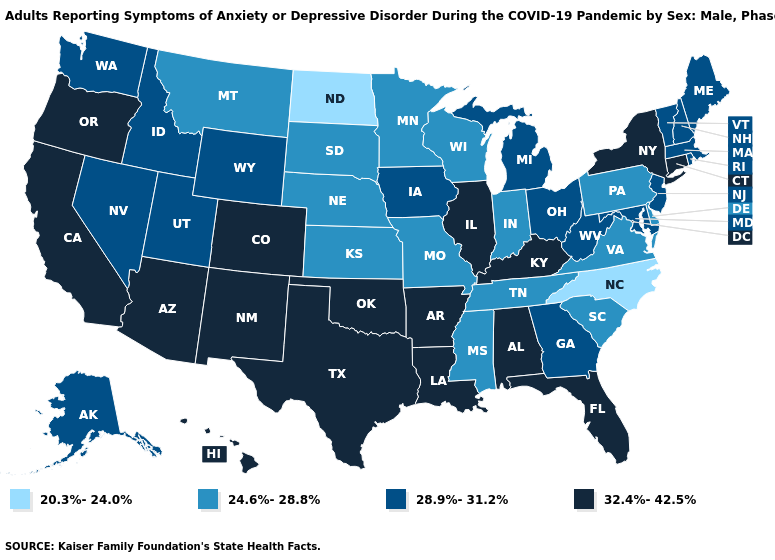Among the states that border Kansas , which have the lowest value?
Quick response, please. Missouri, Nebraska. Which states have the lowest value in the USA?
Answer briefly. North Carolina, North Dakota. Among the states that border Wyoming , which have the lowest value?
Be succinct. Montana, Nebraska, South Dakota. Name the states that have a value in the range 28.9%-31.2%?
Concise answer only. Alaska, Georgia, Idaho, Iowa, Maine, Maryland, Massachusetts, Michigan, Nevada, New Hampshire, New Jersey, Ohio, Rhode Island, Utah, Vermont, Washington, West Virginia, Wyoming. What is the lowest value in the USA?
Concise answer only. 20.3%-24.0%. Does North Dakota have the lowest value in the MidWest?
Write a very short answer. Yes. How many symbols are there in the legend?
Be succinct. 4. Name the states that have a value in the range 24.6%-28.8%?
Be succinct. Delaware, Indiana, Kansas, Minnesota, Mississippi, Missouri, Montana, Nebraska, Pennsylvania, South Carolina, South Dakota, Tennessee, Virginia, Wisconsin. What is the value of Louisiana?
Write a very short answer. 32.4%-42.5%. Which states have the highest value in the USA?
Be succinct. Alabama, Arizona, Arkansas, California, Colorado, Connecticut, Florida, Hawaii, Illinois, Kentucky, Louisiana, New Mexico, New York, Oklahoma, Oregon, Texas. Among the states that border South Dakota , which have the highest value?
Write a very short answer. Iowa, Wyoming. What is the value of Indiana?
Quick response, please. 24.6%-28.8%. Is the legend a continuous bar?
Give a very brief answer. No. What is the value of New Jersey?
Quick response, please. 28.9%-31.2%. What is the value of Kansas?
Quick response, please. 24.6%-28.8%. 